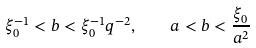Convert formula to latex. <formula><loc_0><loc_0><loc_500><loc_500>\xi _ { 0 } ^ { - 1 } < b < \xi _ { 0 } ^ { - 1 } q ^ { - 2 } , \quad a < b < \frac { \xi _ { 0 } } { a ^ { 2 } }</formula> 